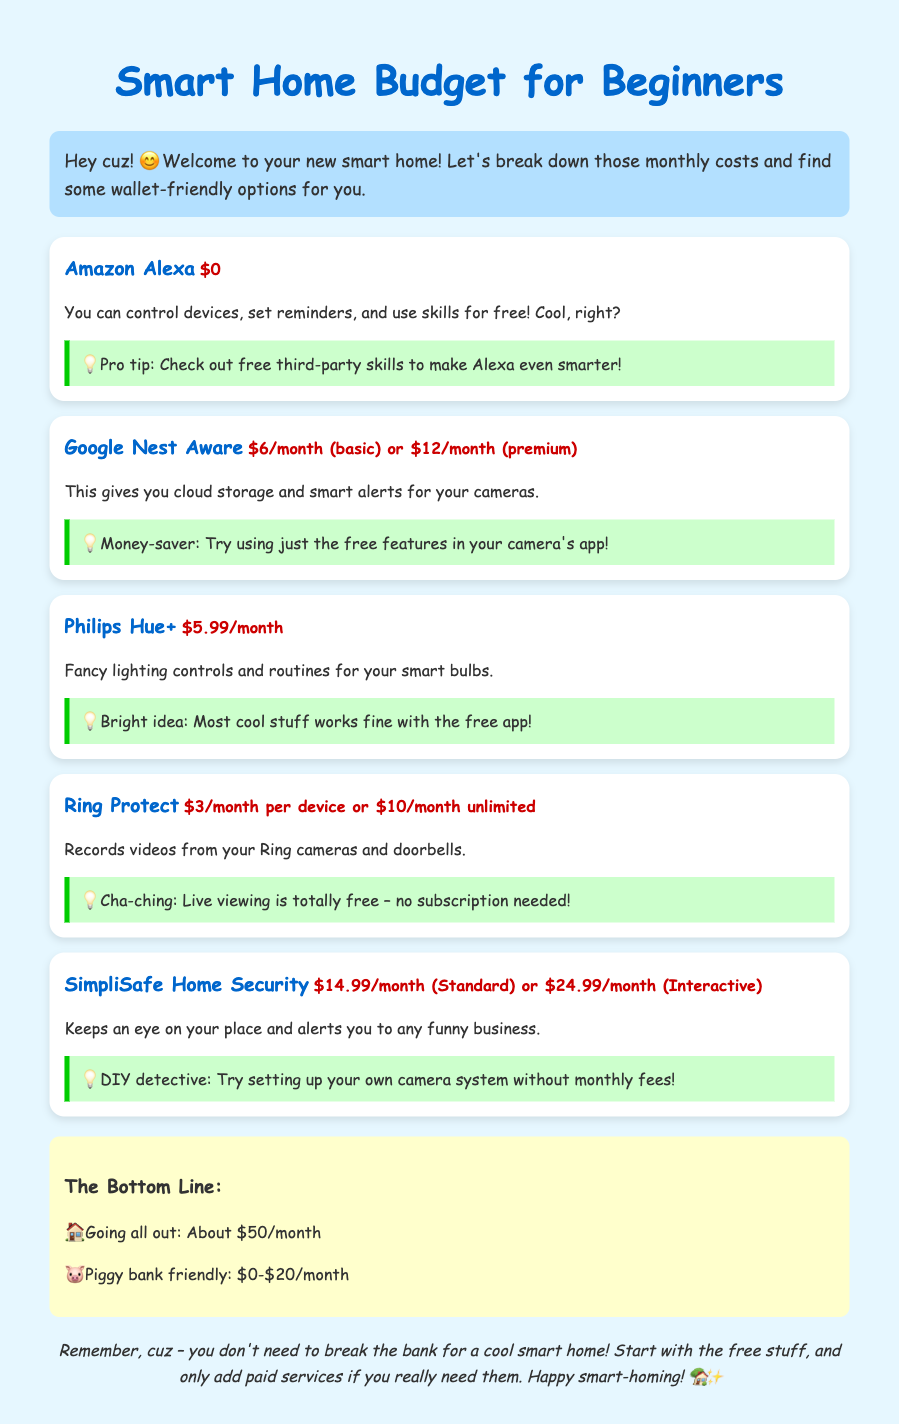What is the subscription cost for Google Nest Aware? The document states that Google Nest Aware has two subscription options: $6 for basic or $12 for premium.
Answer: $6/month (basic) or $12/month (premium) How much does Ring Protect cost for unlimited devices? According to the document, the monthly cost for Ring Protect for unlimited devices is provided directly.
Answer: $10/month What app can control Philips Hue? The document mentions a specific app associated with Philips Hue that maintains functionalities.
Answer: free app What is the main service provided by SimpliSafe Home Security? The document describes that SimpliSafe Home Security keeps watch over your place and alerts.
Answer: Keeps an eye on your place What is the monthly total if one were to subscribe to everything? The document gives a total for a full subscription setup across all mentioned services.
Answer: About $50/month Which service offers free third-party skills? The document explicitly states that Alexa provides this feature without a cost.
Answer: Amazon Alexa What can you do for free with Ring cameras? The document mentions a feature that doesn't require a subscription for Ring cameras.
Answer: Live viewing What should you consider before subscribing to paid services? The concluding advice in the document emphasizes a particular approach to spending on services.
Answer: Use free stuff first 